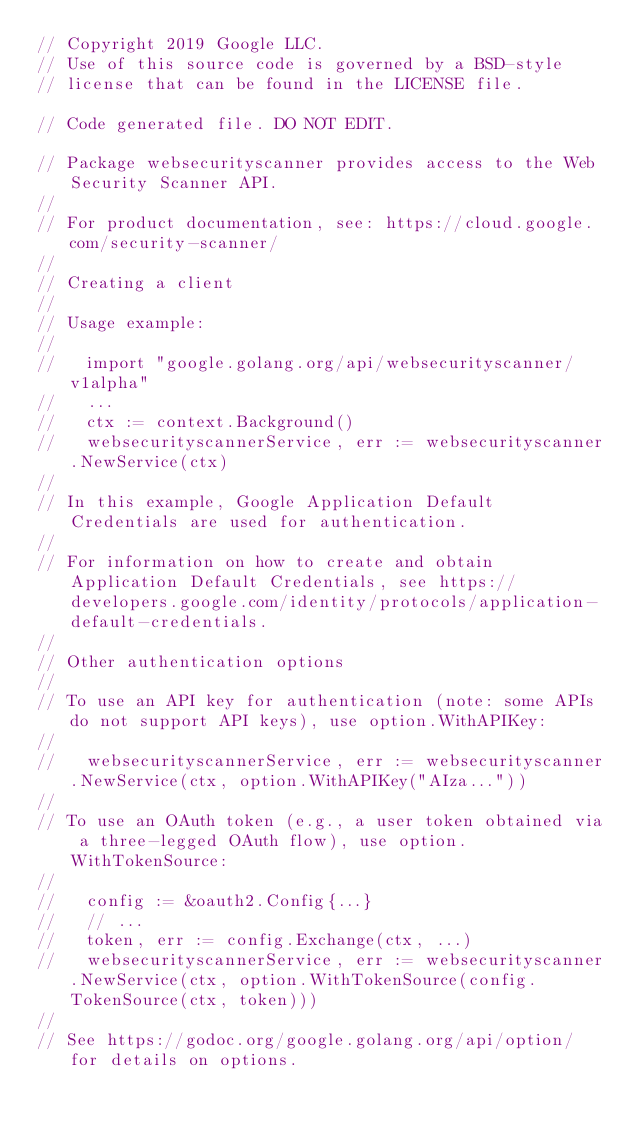Convert code to text. <code><loc_0><loc_0><loc_500><loc_500><_Go_>// Copyright 2019 Google LLC.
// Use of this source code is governed by a BSD-style
// license that can be found in the LICENSE file.

// Code generated file. DO NOT EDIT.

// Package websecurityscanner provides access to the Web Security Scanner API.
//
// For product documentation, see: https://cloud.google.com/security-scanner/
//
// Creating a client
//
// Usage example:
//
//   import "google.golang.org/api/websecurityscanner/v1alpha"
//   ...
//   ctx := context.Background()
//   websecurityscannerService, err := websecurityscanner.NewService(ctx)
//
// In this example, Google Application Default Credentials are used for authentication.
//
// For information on how to create and obtain Application Default Credentials, see https://developers.google.com/identity/protocols/application-default-credentials.
//
// Other authentication options
//
// To use an API key for authentication (note: some APIs do not support API keys), use option.WithAPIKey:
//
//   websecurityscannerService, err := websecurityscanner.NewService(ctx, option.WithAPIKey("AIza..."))
//
// To use an OAuth token (e.g., a user token obtained via a three-legged OAuth flow), use option.WithTokenSource:
//
//   config := &oauth2.Config{...}
//   // ...
//   token, err := config.Exchange(ctx, ...)
//   websecurityscannerService, err := websecurityscanner.NewService(ctx, option.WithTokenSource(config.TokenSource(ctx, token)))
//
// See https://godoc.org/google.golang.org/api/option/ for details on options.</code> 